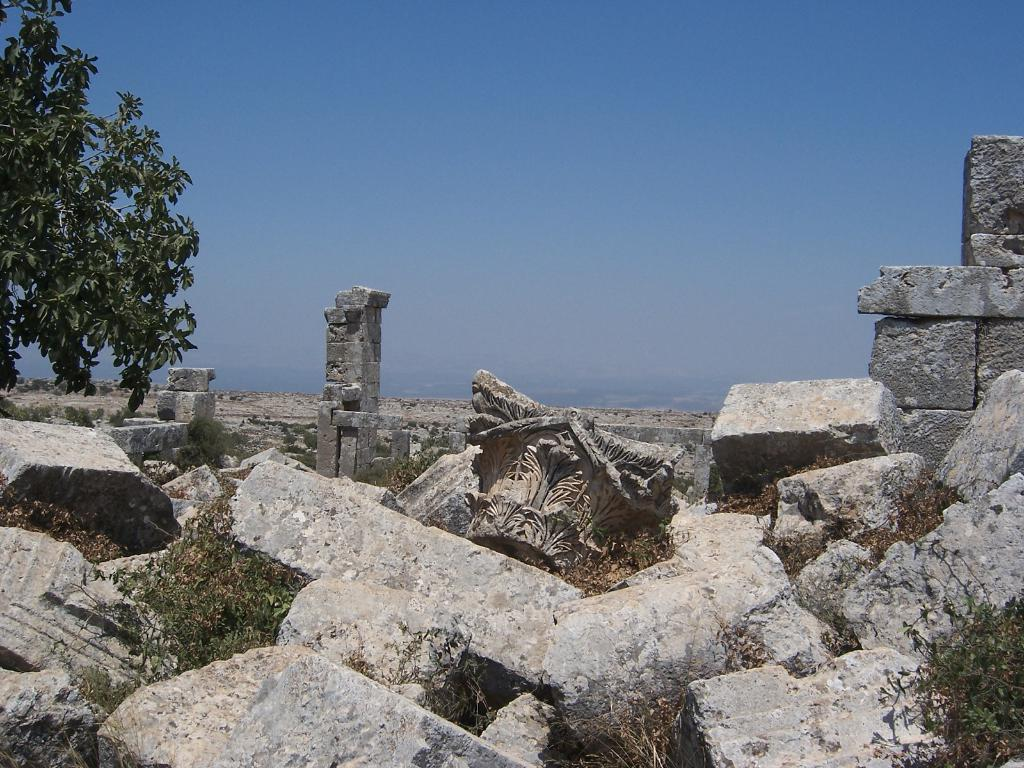What type of natural elements can be seen in the front of the image? There are rocks in the front of the image. What type of vegetation is visible in the background of the image? There are trees in the background of the image. What is visible in the sky in the background of the image? The sky is visible in the background of the image. How many noses can be seen on the rocks in the image? There are no noses present in the image; it features rocks and trees. What type of bucket is visible in the background of the image? There is no bucket present in the image; it features rocks, trees, and the sky. 